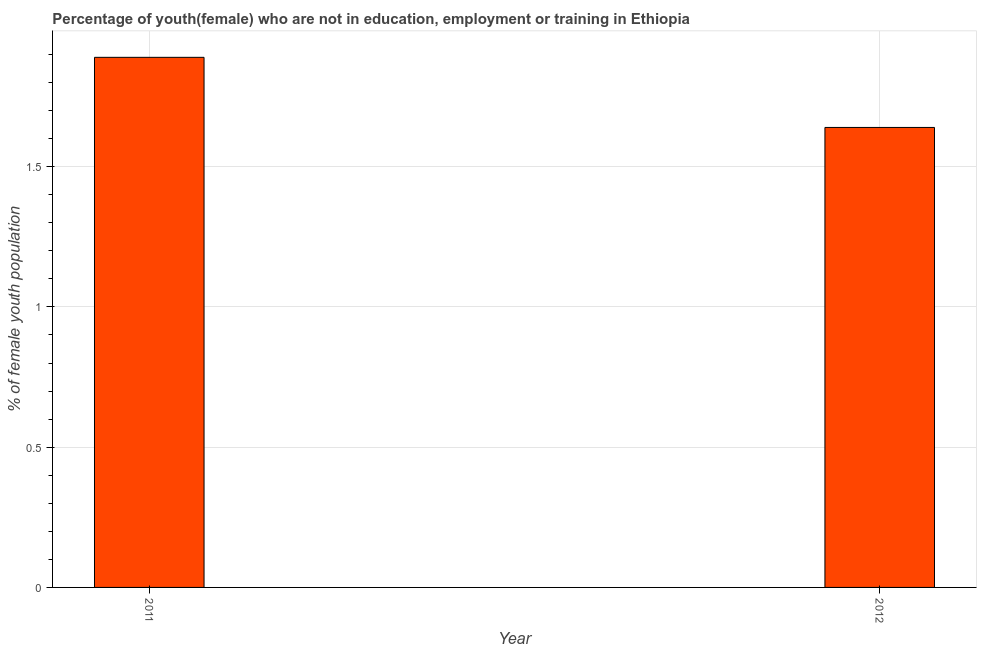Does the graph contain any zero values?
Make the answer very short. No. Does the graph contain grids?
Provide a succinct answer. Yes. What is the title of the graph?
Offer a very short reply. Percentage of youth(female) who are not in education, employment or training in Ethiopia. What is the label or title of the X-axis?
Your answer should be very brief. Year. What is the label or title of the Y-axis?
Keep it short and to the point. % of female youth population. What is the unemployed female youth population in 2011?
Make the answer very short. 1.89. Across all years, what is the maximum unemployed female youth population?
Your answer should be very brief. 1.89. Across all years, what is the minimum unemployed female youth population?
Your answer should be compact. 1.64. In which year was the unemployed female youth population minimum?
Ensure brevity in your answer.  2012. What is the sum of the unemployed female youth population?
Your response must be concise. 3.53. What is the average unemployed female youth population per year?
Your answer should be compact. 1.76. What is the median unemployed female youth population?
Your answer should be compact. 1.76. What is the ratio of the unemployed female youth population in 2011 to that in 2012?
Keep it short and to the point. 1.15. In how many years, is the unemployed female youth population greater than the average unemployed female youth population taken over all years?
Your response must be concise. 1. Are all the bars in the graph horizontal?
Your answer should be compact. No. Are the values on the major ticks of Y-axis written in scientific E-notation?
Offer a very short reply. No. What is the % of female youth population of 2011?
Give a very brief answer. 1.89. What is the % of female youth population of 2012?
Offer a very short reply. 1.64. What is the difference between the % of female youth population in 2011 and 2012?
Provide a short and direct response. 0.25. What is the ratio of the % of female youth population in 2011 to that in 2012?
Your answer should be compact. 1.15. 